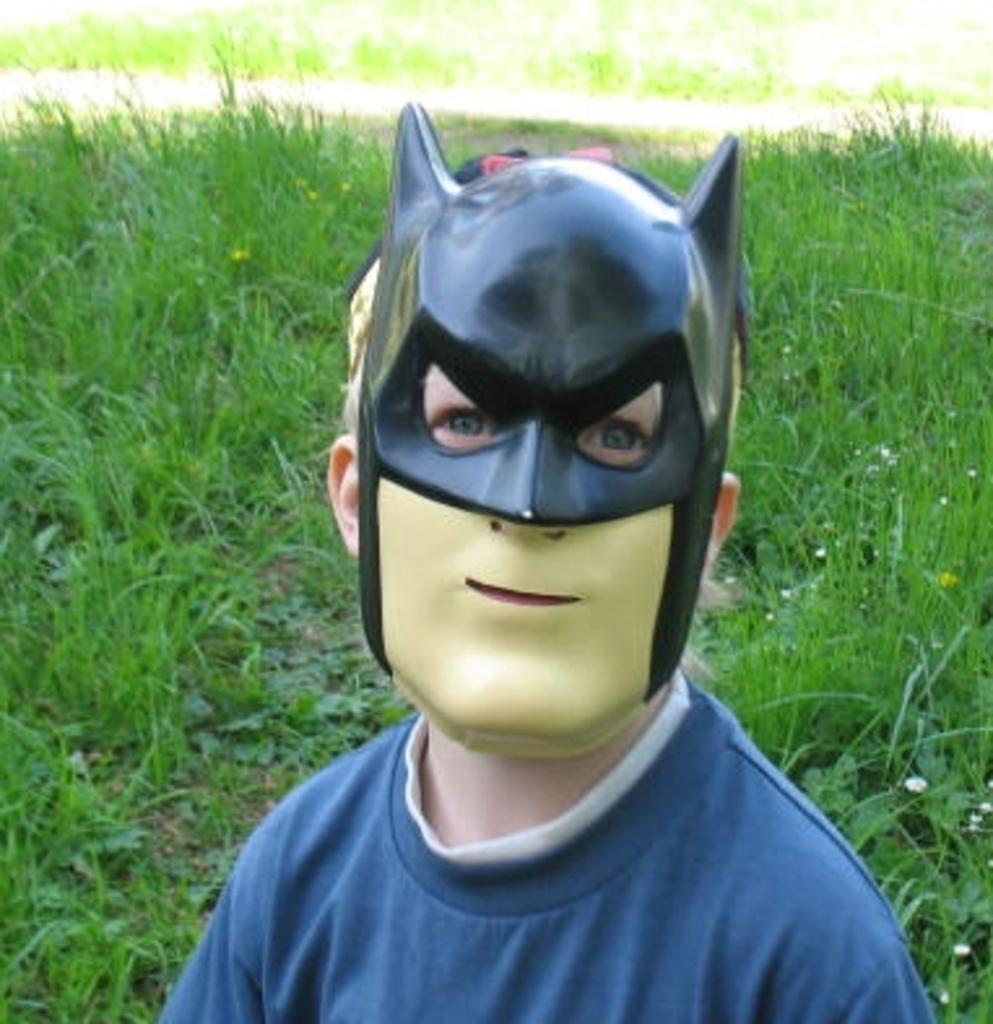Please provide a concise description of this image. In this image we can see a person wearing a mask and there are some plants on the ground. 